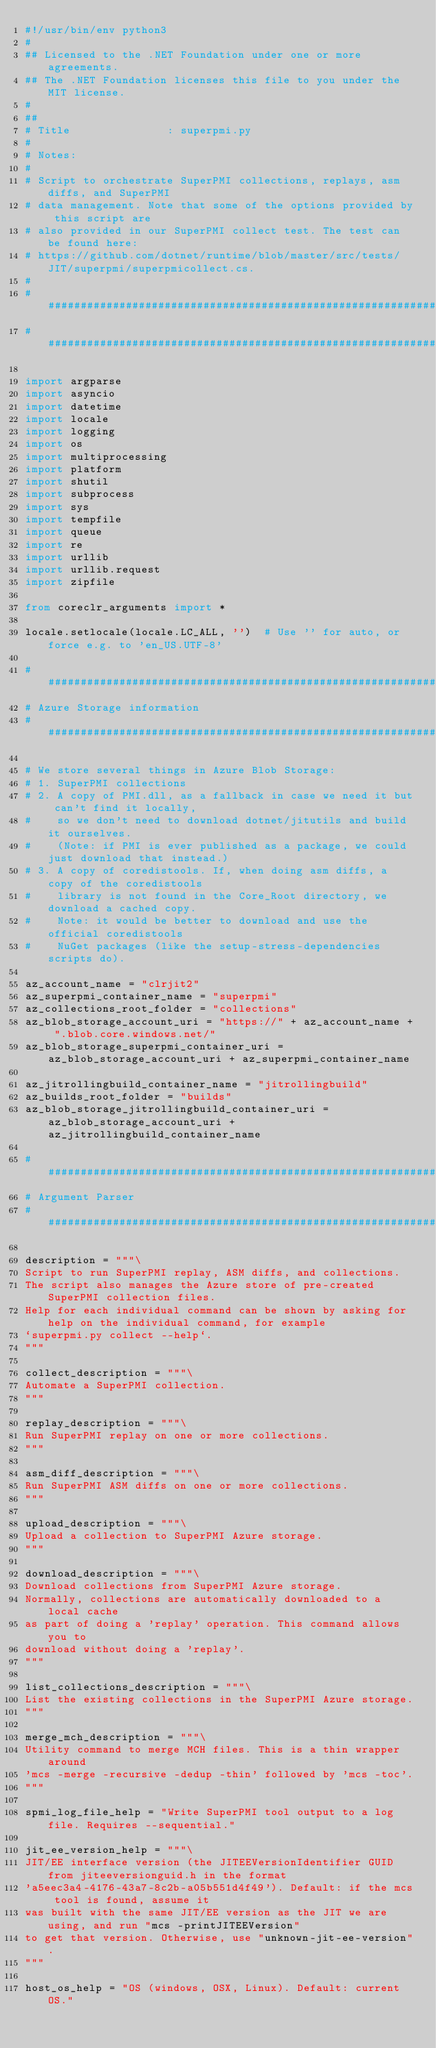Convert code to text. <code><loc_0><loc_0><loc_500><loc_500><_Python_>#!/usr/bin/env python3
#
## Licensed to the .NET Foundation under one or more agreements.
## The .NET Foundation licenses this file to you under the MIT license.
#
##
# Title               : superpmi.py
#
# Notes:
#
# Script to orchestrate SuperPMI collections, replays, asm diffs, and SuperPMI
# data management. Note that some of the options provided by this script are
# also provided in our SuperPMI collect test. The test can be found here:
# https://github.com/dotnet/runtime/blob/master/src/tests/JIT/superpmi/superpmicollect.cs.
#
################################################################################
################################################################################

import argparse
import asyncio
import datetime
import locale
import logging
import os
import multiprocessing
import platform
import shutil
import subprocess
import sys
import tempfile
import queue
import re
import urllib
import urllib.request
import zipfile

from coreclr_arguments import *

locale.setlocale(locale.LC_ALL, '')  # Use '' for auto, or force e.g. to 'en_US.UTF-8'

################################################################################
# Azure Storage information
################################################################################

# We store several things in Azure Blob Storage:
# 1. SuperPMI collections
# 2. A copy of PMI.dll, as a fallback in case we need it but can't find it locally,
#    so we don't need to download dotnet/jitutils and build it ourselves.
#    (Note: if PMI is ever published as a package, we could just download that instead.)
# 3. A copy of coredistools. If, when doing asm diffs, a copy of the coredistools
#    library is not found in the Core_Root directory, we download a cached copy.
#    Note: it would be better to download and use the official coredistools
#    NuGet packages (like the setup-stress-dependencies scripts do).

az_account_name = "clrjit2"
az_superpmi_container_name = "superpmi"
az_collections_root_folder = "collections"
az_blob_storage_account_uri = "https://" + az_account_name + ".blob.core.windows.net/"
az_blob_storage_superpmi_container_uri = az_blob_storage_account_uri + az_superpmi_container_name

az_jitrollingbuild_container_name = "jitrollingbuild"
az_builds_root_folder = "builds"
az_blob_storage_jitrollingbuild_container_uri = az_blob_storage_account_uri + az_jitrollingbuild_container_name

################################################################################
# Argument Parser
################################################################################

description = """\
Script to run SuperPMI replay, ASM diffs, and collections.
The script also manages the Azure store of pre-created SuperPMI collection files.
Help for each individual command can be shown by asking for help on the individual command, for example
`superpmi.py collect --help`.
"""

collect_description = """\
Automate a SuperPMI collection.
"""

replay_description = """\
Run SuperPMI replay on one or more collections.
"""

asm_diff_description = """\
Run SuperPMI ASM diffs on one or more collections.
"""

upload_description = """\
Upload a collection to SuperPMI Azure storage.
"""

download_description = """\
Download collections from SuperPMI Azure storage.
Normally, collections are automatically downloaded to a local cache
as part of doing a 'replay' operation. This command allows you to
download without doing a 'replay'.
"""

list_collections_description = """\
List the existing collections in the SuperPMI Azure storage.
"""

merge_mch_description = """\
Utility command to merge MCH files. This is a thin wrapper around
'mcs -merge -recursive -dedup -thin' followed by 'mcs -toc'.
"""

spmi_log_file_help = "Write SuperPMI tool output to a log file. Requires --sequential."

jit_ee_version_help = """\
JIT/EE interface version (the JITEEVersionIdentifier GUID from jiteeversionguid.h in the format
'a5eec3a4-4176-43a7-8c2b-a05b551d4f49'). Default: if the mcs tool is found, assume it
was built with the same JIT/EE version as the JIT we are using, and run "mcs -printJITEEVersion"
to get that version. Otherwise, use "unknown-jit-ee-version".
"""

host_os_help = "OS (windows, OSX, Linux). Default: current OS."
</code> 